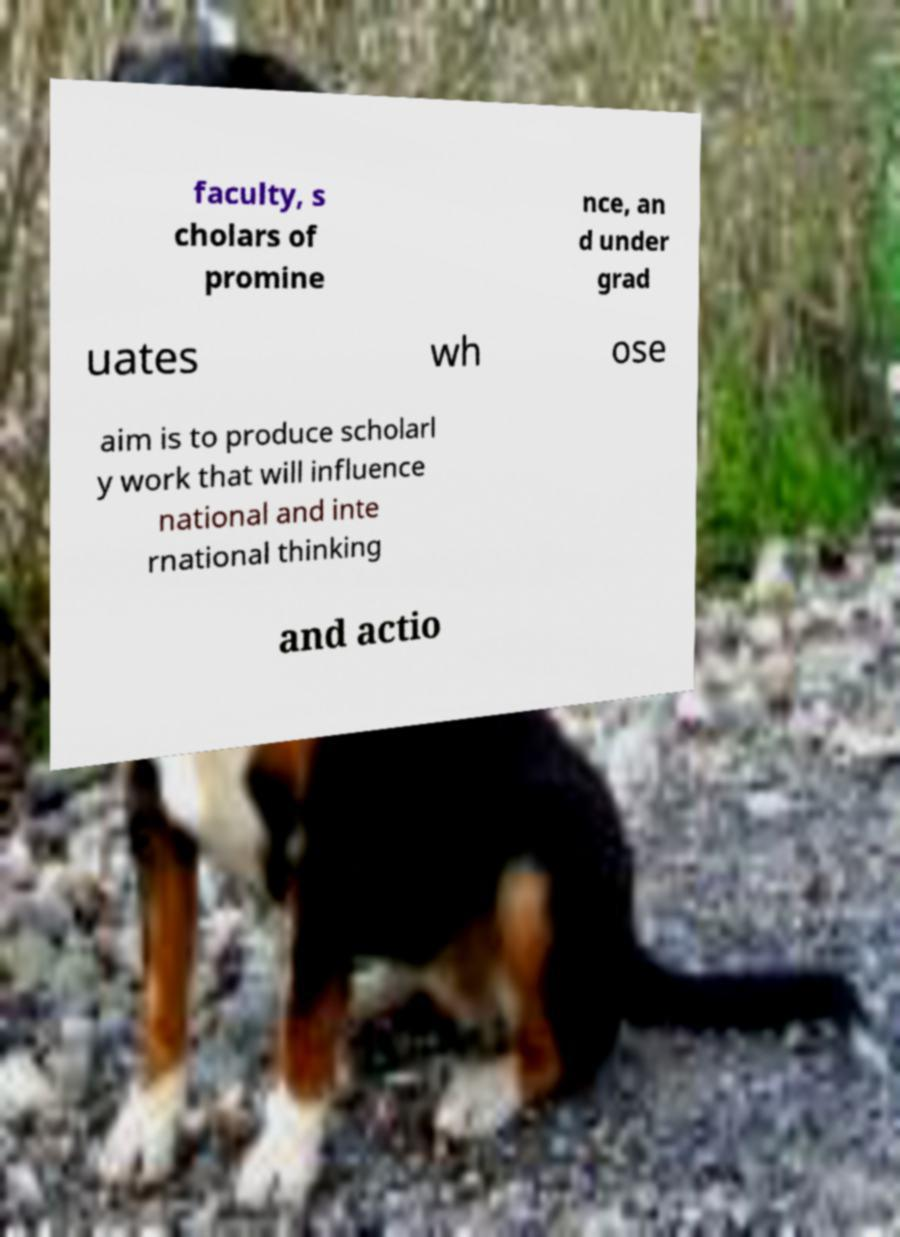What messages or text are displayed in this image? I need them in a readable, typed format. faculty, s cholars of promine nce, an d under grad uates wh ose aim is to produce scholarl y work that will influence national and inte rnational thinking and actio 